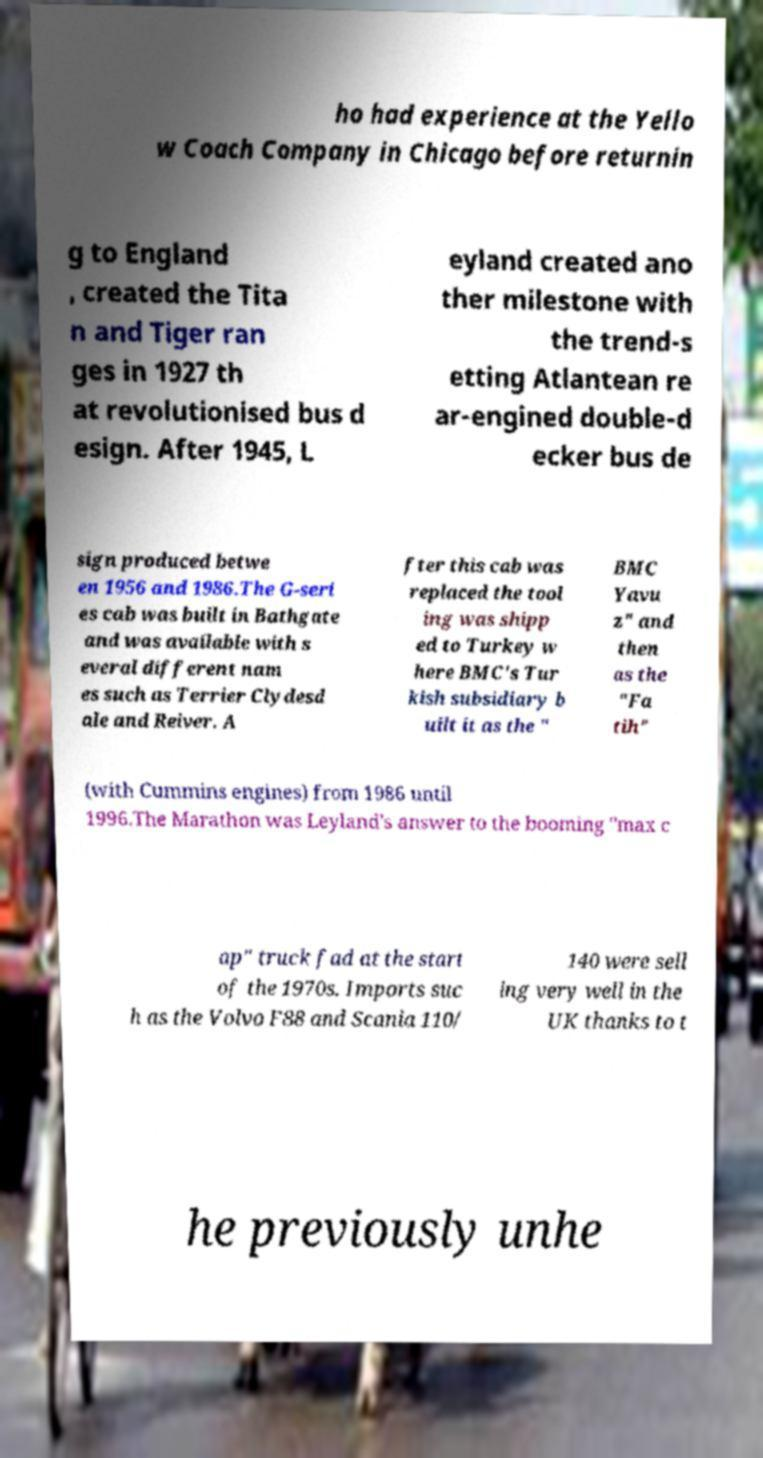Could you extract and type out the text from this image? ho had experience at the Yello w Coach Company in Chicago before returnin g to England , created the Tita n and Tiger ran ges in 1927 th at revolutionised bus d esign. After 1945, L eyland created ano ther milestone with the trend-s etting Atlantean re ar-engined double-d ecker bus de sign produced betwe en 1956 and 1986.The G-seri es cab was built in Bathgate and was available with s everal different nam es such as Terrier Clydesd ale and Reiver. A fter this cab was replaced the tool ing was shipp ed to Turkey w here BMC's Tur kish subsidiary b uilt it as the " BMC Yavu z" and then as the "Fa tih" (with Cummins engines) from 1986 until 1996.The Marathon was Leyland's answer to the booming "max c ap" truck fad at the start of the 1970s. Imports suc h as the Volvo F88 and Scania 110/ 140 were sell ing very well in the UK thanks to t he previously unhe 